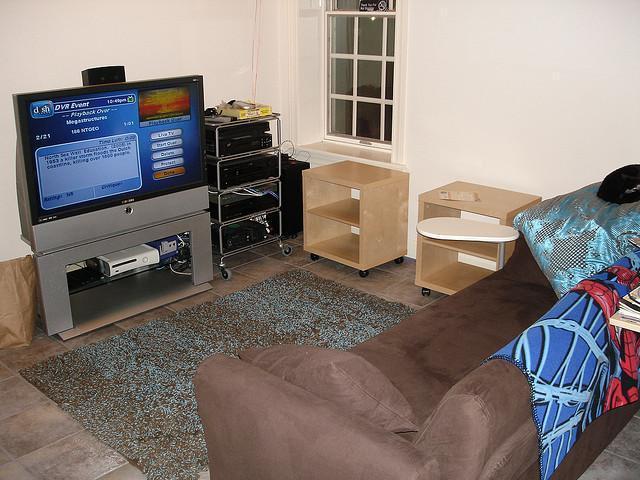How many people have dress ties on?
Give a very brief answer. 0. 